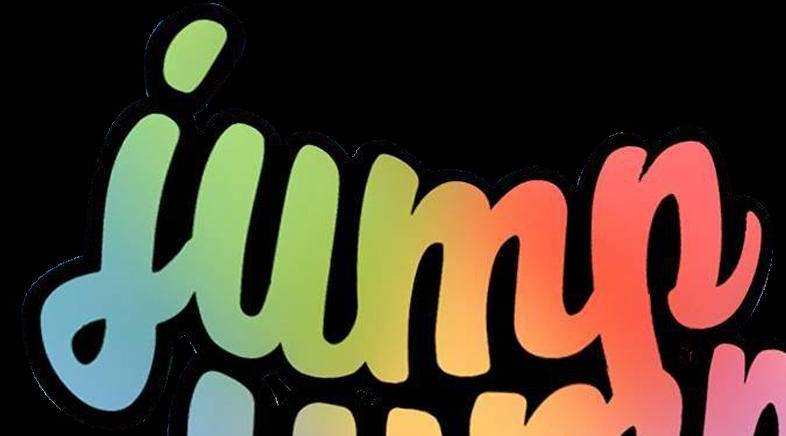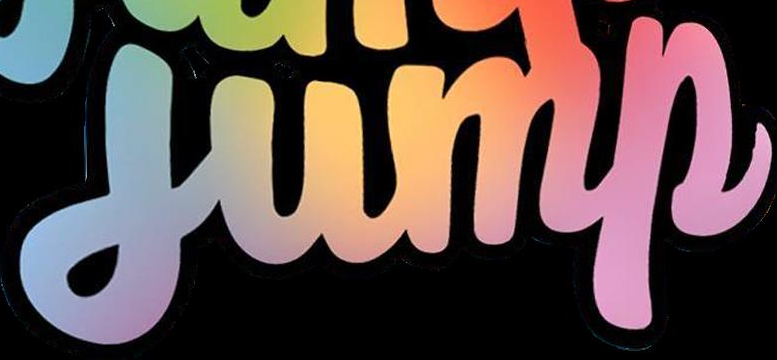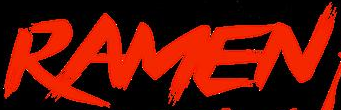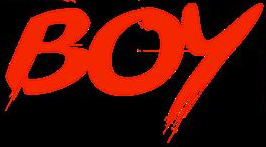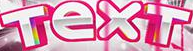Read the text from these images in sequence, separated by a semicolon. jump; jump; RAMEN; BOY; TexT 